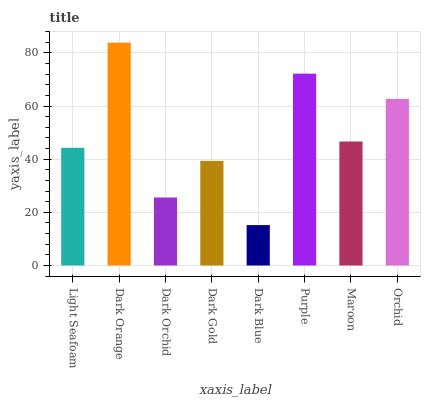Is Dark Blue the minimum?
Answer yes or no. Yes. Is Dark Orange the maximum?
Answer yes or no. Yes. Is Dark Orchid the minimum?
Answer yes or no. No. Is Dark Orchid the maximum?
Answer yes or no. No. Is Dark Orange greater than Dark Orchid?
Answer yes or no. Yes. Is Dark Orchid less than Dark Orange?
Answer yes or no. Yes. Is Dark Orchid greater than Dark Orange?
Answer yes or no. No. Is Dark Orange less than Dark Orchid?
Answer yes or no. No. Is Maroon the high median?
Answer yes or no. Yes. Is Light Seafoam the low median?
Answer yes or no. Yes. Is Dark Gold the high median?
Answer yes or no. No. Is Dark Orchid the low median?
Answer yes or no. No. 